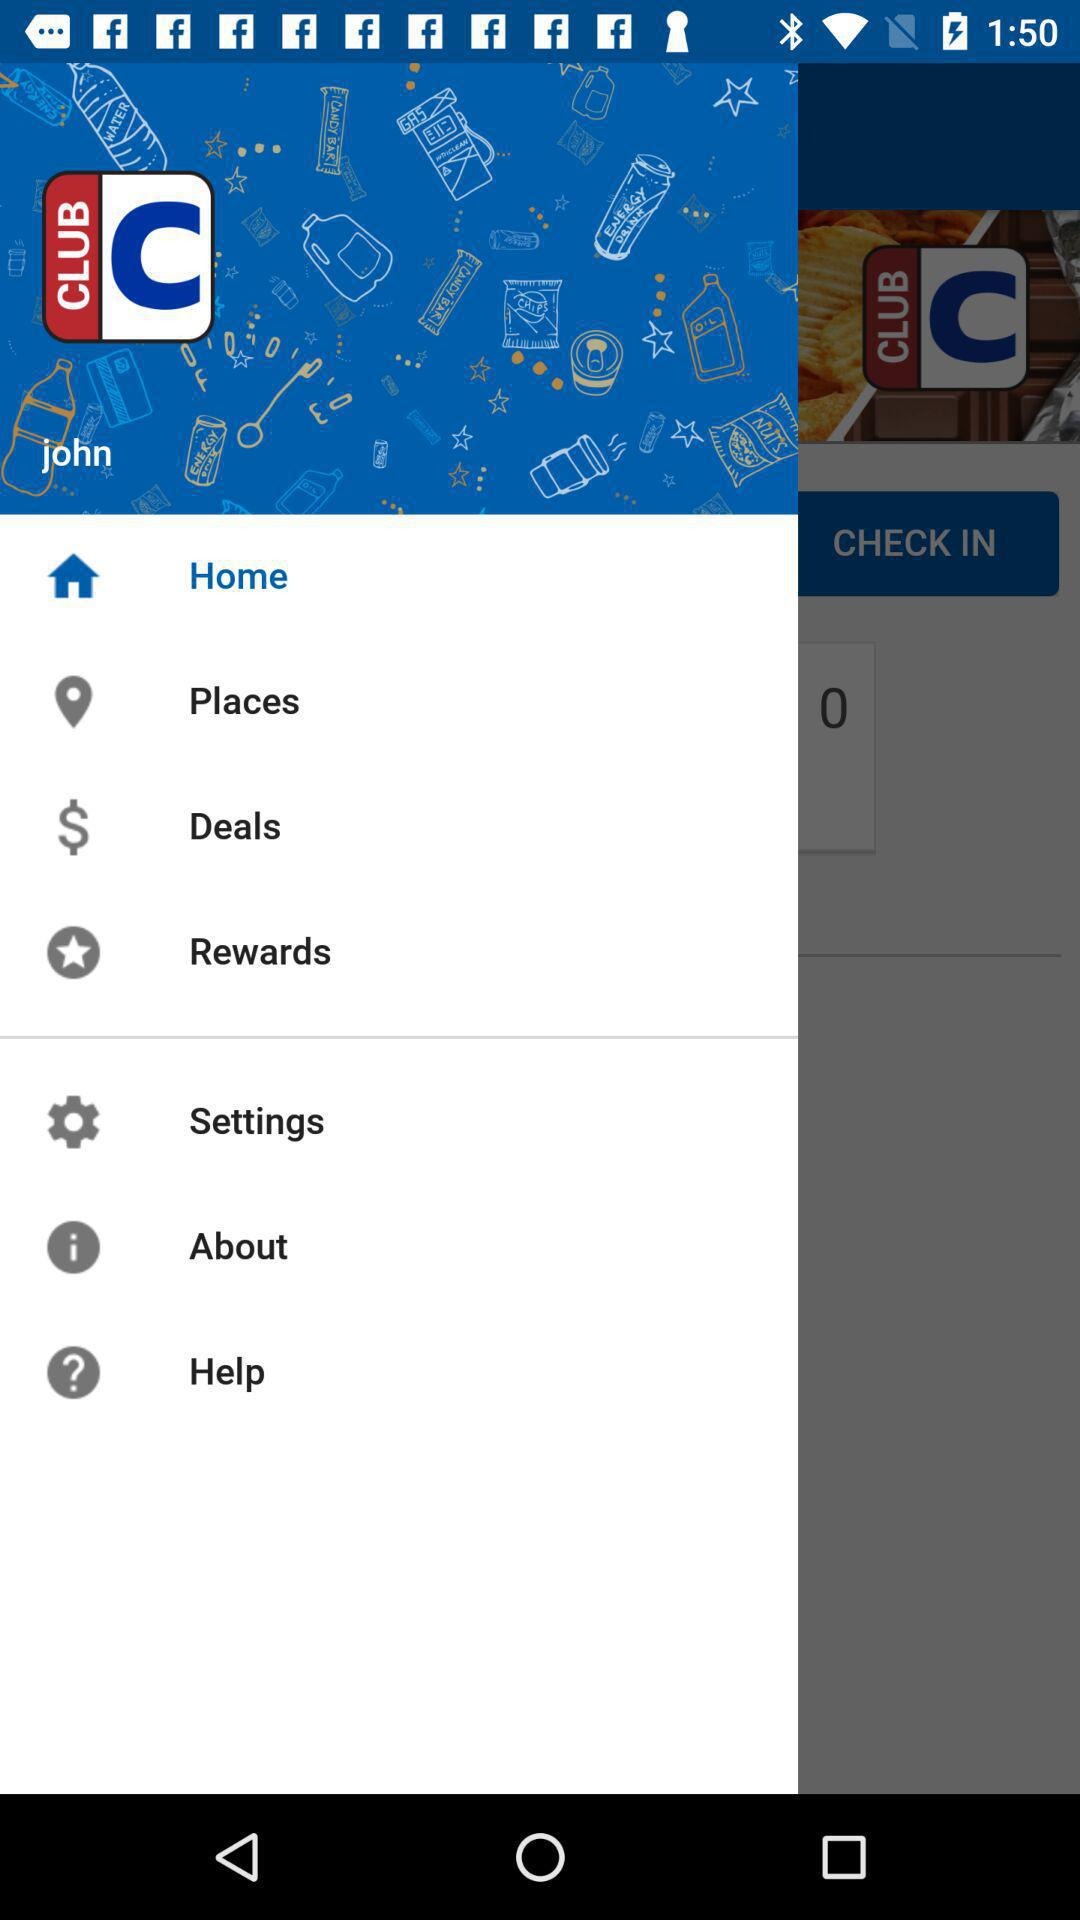What is the username? The username is "john". 